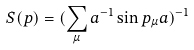<formula> <loc_0><loc_0><loc_500><loc_500>S ( p ) = ( \sum _ { \mu } a ^ { - 1 } \sin p _ { \mu } a ) ^ { - 1 }</formula> 